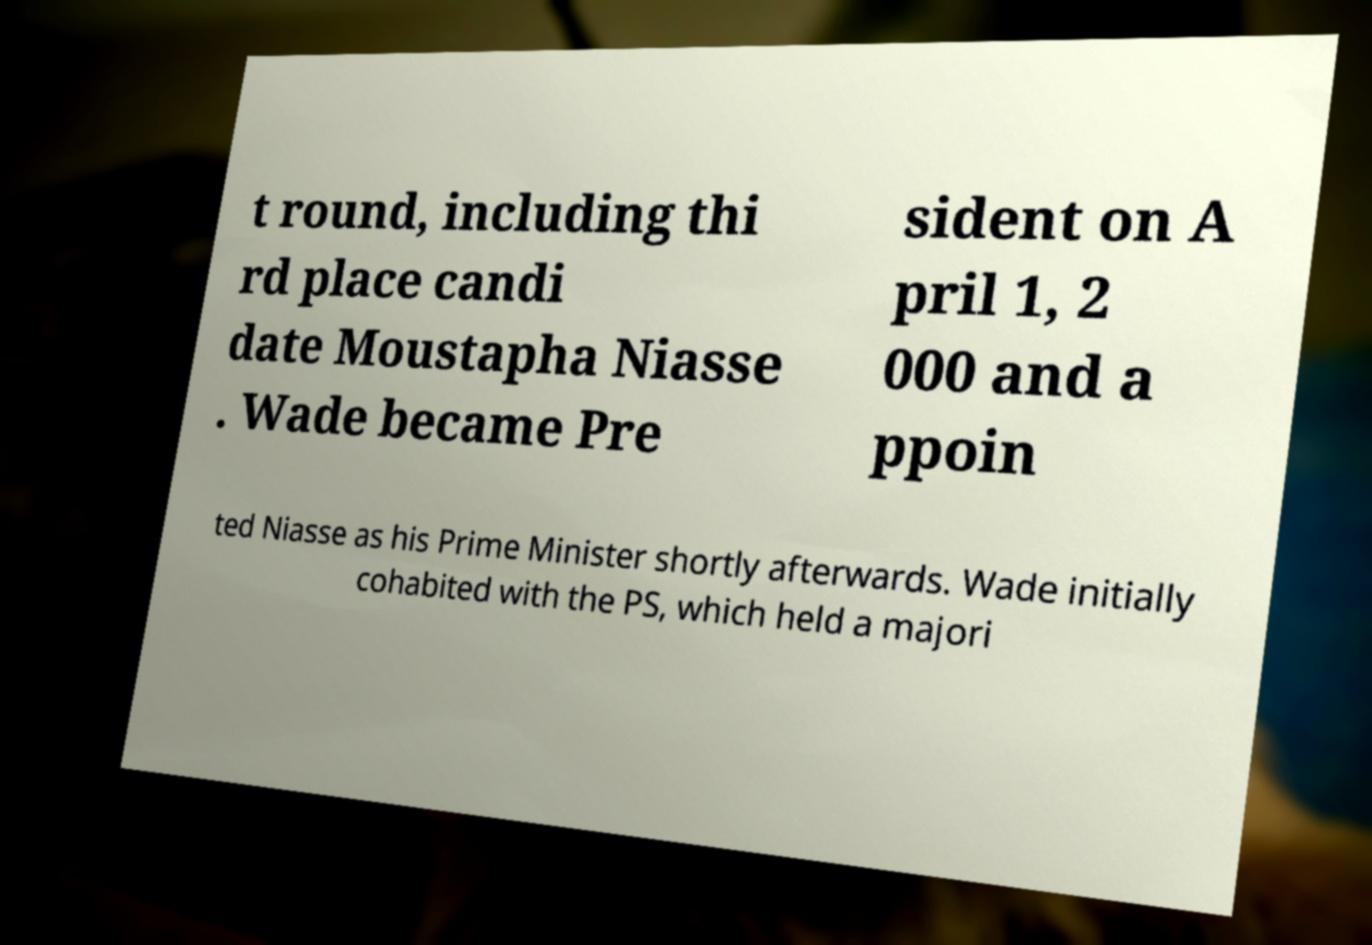Could you assist in decoding the text presented in this image and type it out clearly? t round, including thi rd place candi date Moustapha Niasse . Wade became Pre sident on A pril 1, 2 000 and a ppoin ted Niasse as his Prime Minister shortly afterwards. Wade initially cohabited with the PS, which held a majori 